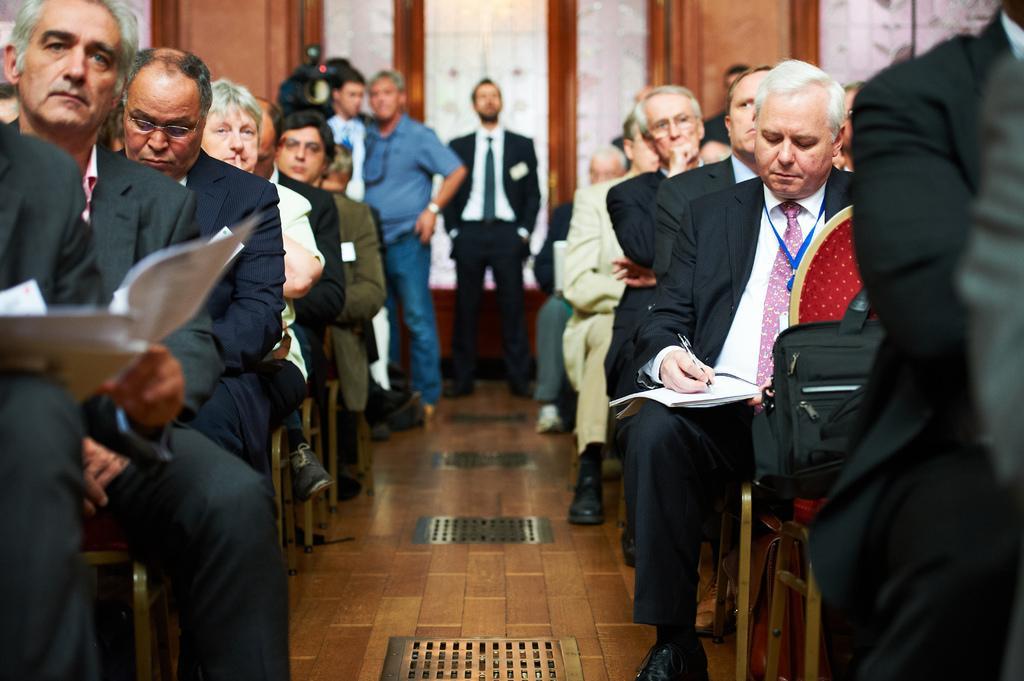Could you give a brief overview of what you see in this image? In the center of the image we can see three people are standing and a man is holding a camera. In the background of the image we can see the wall, doors and some people are sitting on the chairs and some of them are holding books and a man is writing on the book with pen and also we can see a bag. At the bottom of the image we can see the floor. 